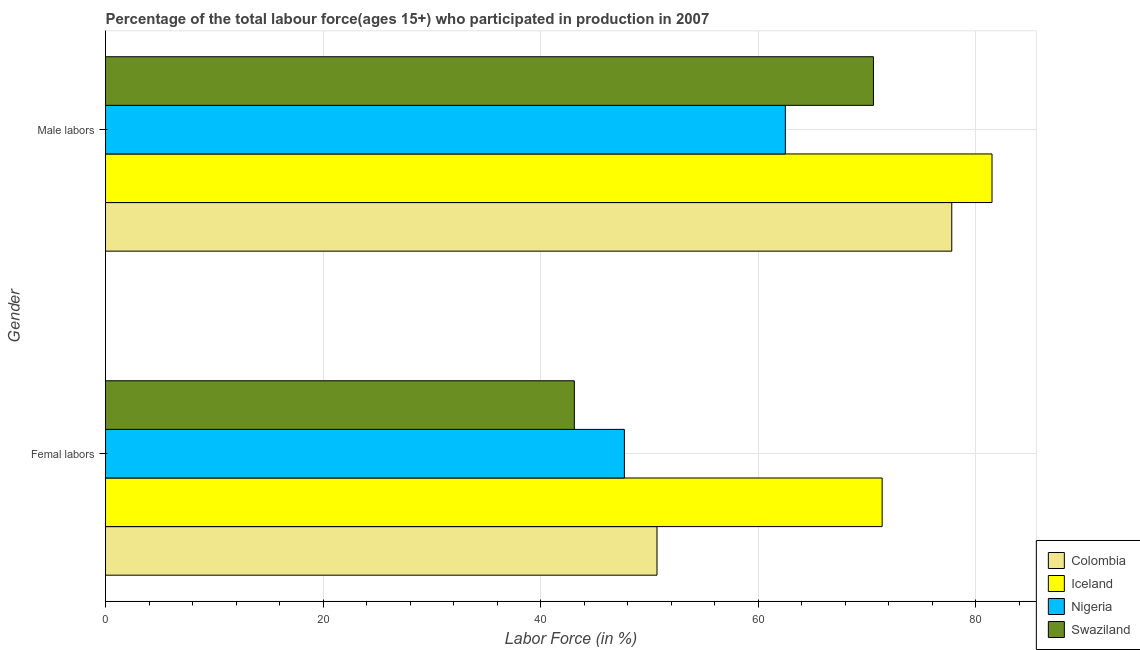Are the number of bars per tick equal to the number of legend labels?
Ensure brevity in your answer.  Yes. How many bars are there on the 2nd tick from the bottom?
Offer a very short reply. 4. What is the label of the 1st group of bars from the top?
Ensure brevity in your answer.  Male labors. What is the percentage of male labour force in Iceland?
Make the answer very short. 81.5. Across all countries, what is the maximum percentage of male labour force?
Offer a very short reply. 81.5. Across all countries, what is the minimum percentage of female labor force?
Provide a succinct answer. 43.1. In which country was the percentage of female labor force minimum?
Ensure brevity in your answer.  Swaziland. What is the total percentage of male labour force in the graph?
Give a very brief answer. 292.4. What is the difference between the percentage of female labor force in Iceland and that in Nigeria?
Offer a very short reply. 23.7. What is the difference between the percentage of female labor force in Colombia and the percentage of male labour force in Nigeria?
Provide a short and direct response. -11.8. What is the average percentage of female labor force per country?
Your answer should be very brief. 53.23. What is the difference between the percentage of female labor force and percentage of male labour force in Colombia?
Give a very brief answer. -27.1. What is the ratio of the percentage of female labor force in Colombia to that in Nigeria?
Your answer should be very brief. 1.06. In how many countries, is the percentage of female labor force greater than the average percentage of female labor force taken over all countries?
Provide a succinct answer. 1. What does the 2nd bar from the top in Male labors represents?
Your answer should be very brief. Nigeria. What does the 4th bar from the bottom in Male labors represents?
Your response must be concise. Swaziland. How many bars are there?
Keep it short and to the point. 8. Are all the bars in the graph horizontal?
Ensure brevity in your answer.  Yes. How many countries are there in the graph?
Give a very brief answer. 4. Are the values on the major ticks of X-axis written in scientific E-notation?
Ensure brevity in your answer.  No. Does the graph contain any zero values?
Provide a short and direct response. No. How are the legend labels stacked?
Your response must be concise. Vertical. What is the title of the graph?
Ensure brevity in your answer.  Percentage of the total labour force(ages 15+) who participated in production in 2007. What is the label or title of the X-axis?
Your answer should be compact. Labor Force (in %). What is the label or title of the Y-axis?
Make the answer very short. Gender. What is the Labor Force (in %) of Colombia in Femal labors?
Offer a terse response. 50.7. What is the Labor Force (in %) of Iceland in Femal labors?
Make the answer very short. 71.4. What is the Labor Force (in %) of Nigeria in Femal labors?
Provide a short and direct response. 47.7. What is the Labor Force (in %) in Swaziland in Femal labors?
Offer a very short reply. 43.1. What is the Labor Force (in %) in Colombia in Male labors?
Provide a short and direct response. 77.8. What is the Labor Force (in %) of Iceland in Male labors?
Give a very brief answer. 81.5. What is the Labor Force (in %) of Nigeria in Male labors?
Offer a terse response. 62.5. What is the Labor Force (in %) in Swaziland in Male labors?
Keep it short and to the point. 70.6. Across all Gender, what is the maximum Labor Force (in %) in Colombia?
Your answer should be compact. 77.8. Across all Gender, what is the maximum Labor Force (in %) in Iceland?
Your response must be concise. 81.5. Across all Gender, what is the maximum Labor Force (in %) of Nigeria?
Your response must be concise. 62.5. Across all Gender, what is the maximum Labor Force (in %) of Swaziland?
Offer a terse response. 70.6. Across all Gender, what is the minimum Labor Force (in %) in Colombia?
Your answer should be compact. 50.7. Across all Gender, what is the minimum Labor Force (in %) in Iceland?
Make the answer very short. 71.4. Across all Gender, what is the minimum Labor Force (in %) of Nigeria?
Offer a very short reply. 47.7. Across all Gender, what is the minimum Labor Force (in %) of Swaziland?
Offer a very short reply. 43.1. What is the total Labor Force (in %) of Colombia in the graph?
Offer a terse response. 128.5. What is the total Labor Force (in %) in Iceland in the graph?
Your answer should be very brief. 152.9. What is the total Labor Force (in %) of Nigeria in the graph?
Offer a terse response. 110.2. What is the total Labor Force (in %) of Swaziland in the graph?
Provide a succinct answer. 113.7. What is the difference between the Labor Force (in %) in Colombia in Femal labors and that in Male labors?
Offer a terse response. -27.1. What is the difference between the Labor Force (in %) in Iceland in Femal labors and that in Male labors?
Keep it short and to the point. -10.1. What is the difference between the Labor Force (in %) of Nigeria in Femal labors and that in Male labors?
Your answer should be compact. -14.8. What is the difference between the Labor Force (in %) of Swaziland in Femal labors and that in Male labors?
Your response must be concise. -27.5. What is the difference between the Labor Force (in %) in Colombia in Femal labors and the Labor Force (in %) in Iceland in Male labors?
Provide a short and direct response. -30.8. What is the difference between the Labor Force (in %) of Colombia in Femal labors and the Labor Force (in %) of Nigeria in Male labors?
Give a very brief answer. -11.8. What is the difference between the Labor Force (in %) in Colombia in Femal labors and the Labor Force (in %) in Swaziland in Male labors?
Offer a very short reply. -19.9. What is the difference between the Labor Force (in %) of Nigeria in Femal labors and the Labor Force (in %) of Swaziland in Male labors?
Make the answer very short. -22.9. What is the average Labor Force (in %) in Colombia per Gender?
Offer a terse response. 64.25. What is the average Labor Force (in %) of Iceland per Gender?
Give a very brief answer. 76.45. What is the average Labor Force (in %) of Nigeria per Gender?
Your answer should be compact. 55.1. What is the average Labor Force (in %) in Swaziland per Gender?
Your answer should be very brief. 56.85. What is the difference between the Labor Force (in %) in Colombia and Labor Force (in %) in Iceland in Femal labors?
Your answer should be compact. -20.7. What is the difference between the Labor Force (in %) in Iceland and Labor Force (in %) in Nigeria in Femal labors?
Your answer should be very brief. 23.7. What is the difference between the Labor Force (in %) of Iceland and Labor Force (in %) of Swaziland in Femal labors?
Your response must be concise. 28.3. What is the difference between the Labor Force (in %) in Nigeria and Labor Force (in %) in Swaziland in Femal labors?
Make the answer very short. 4.6. What is the difference between the Labor Force (in %) of Colombia and Labor Force (in %) of Iceland in Male labors?
Ensure brevity in your answer.  -3.7. What is the difference between the Labor Force (in %) of Colombia and Labor Force (in %) of Nigeria in Male labors?
Your response must be concise. 15.3. What is the difference between the Labor Force (in %) of Colombia and Labor Force (in %) of Swaziland in Male labors?
Offer a terse response. 7.2. What is the difference between the Labor Force (in %) of Iceland and Labor Force (in %) of Nigeria in Male labors?
Your answer should be very brief. 19. What is the difference between the Labor Force (in %) in Nigeria and Labor Force (in %) in Swaziland in Male labors?
Give a very brief answer. -8.1. What is the ratio of the Labor Force (in %) in Colombia in Femal labors to that in Male labors?
Ensure brevity in your answer.  0.65. What is the ratio of the Labor Force (in %) of Iceland in Femal labors to that in Male labors?
Your answer should be compact. 0.88. What is the ratio of the Labor Force (in %) of Nigeria in Femal labors to that in Male labors?
Offer a very short reply. 0.76. What is the ratio of the Labor Force (in %) in Swaziland in Femal labors to that in Male labors?
Your response must be concise. 0.61. What is the difference between the highest and the second highest Labor Force (in %) of Colombia?
Give a very brief answer. 27.1. What is the difference between the highest and the second highest Labor Force (in %) of Swaziland?
Your response must be concise. 27.5. What is the difference between the highest and the lowest Labor Force (in %) in Colombia?
Offer a very short reply. 27.1. 